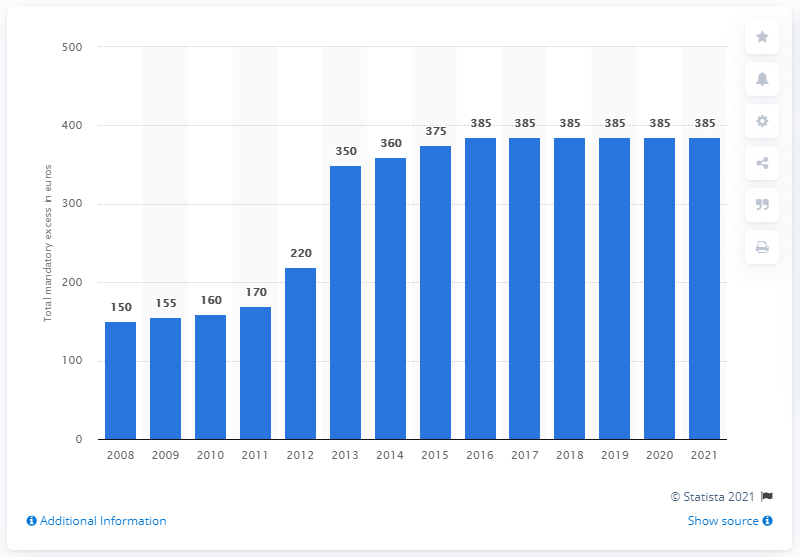Identify some key points in this picture. The Dutch Health Insurance Act was introduced in 2008. 